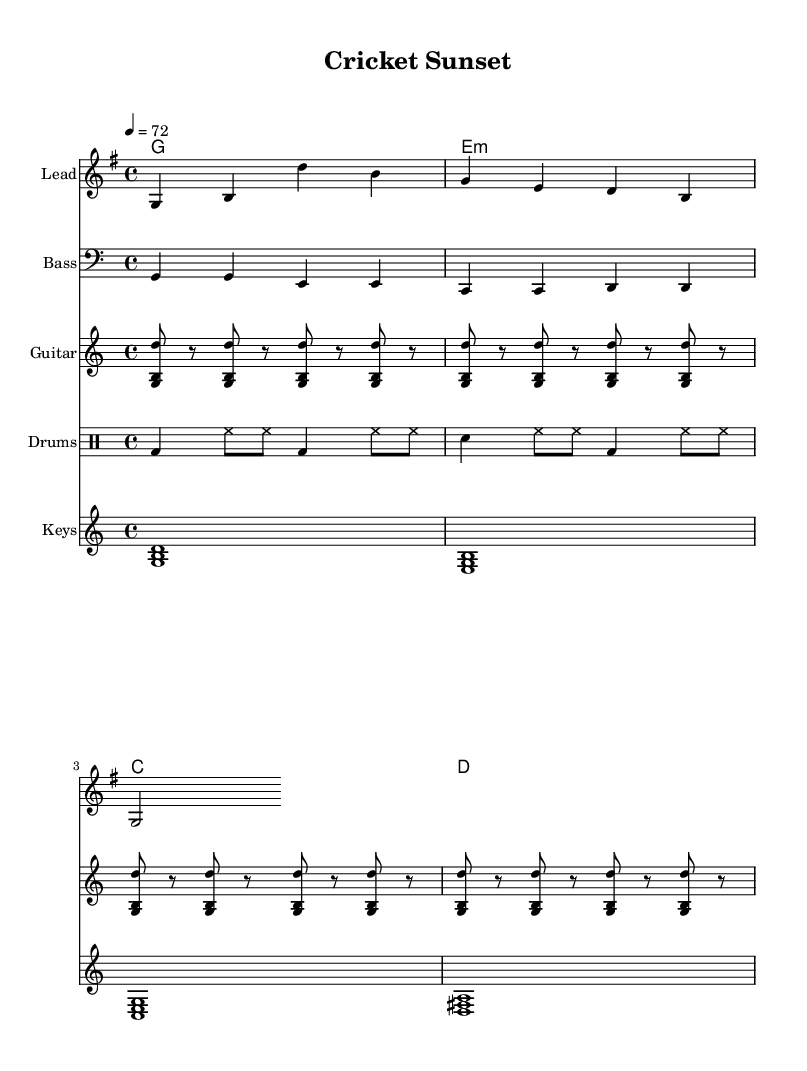What is the key signature of this music? The key signature is G major, which has one sharp (F#). This is indicated at the beginning of the staff.
Answer: G major What is the time signature of this piece? The time signature is 4/4, which means there are four beats in a measure and the quarter note receives one beat. This is noted at the beginning of the score.
Answer: 4/4 What is the tempo marking of this music? The tempo marking is 72 beats per minute, indicated as "4 = 72". This shows the speed at which the piece should be played.
Answer: 72 How many measures does the melody consist of? The melody consists of 3 measures, as seen in the system where the notes are grouped into three distinct sets of bars.
Answer: 3 What is the root chord in the first measure? The root chord in the first measure is G major, which is established by the first chord symbol above the melody.
Answer: G What rhythmic pattern is used in the drums part? The drum part features a combination of bass drums, snare drums, and hi-hats played in a repeating rhythmic pattern across the measures, typical for reggae styles.
Answer: Repeating rhythmic pattern What instrument plays the bass line? The bass line is played by the Bass staff, indicated at the beginning of the part and structured in a way that aligns with the bass notes.
Answer: Bass 